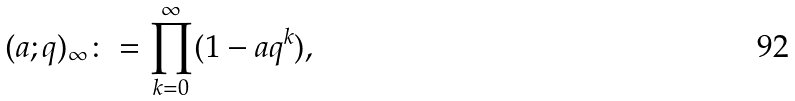<formula> <loc_0><loc_0><loc_500><loc_500>( a ; q ) _ { \infty } \colon = \prod _ { k = 0 } ^ { \infty } ( 1 - a q ^ { k } ) ,</formula> 